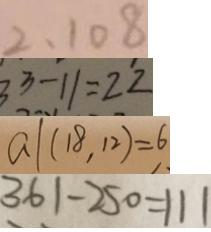<formula> <loc_0><loc_0><loc_500><loc_500>2 , 1 0 8 
 3 3 - 1 1 = 2 2 
 a \vert ( 1 8 , 1 2 ) = 6 
 3 6 1 - 2 5 0 = 1 1 1</formula> 